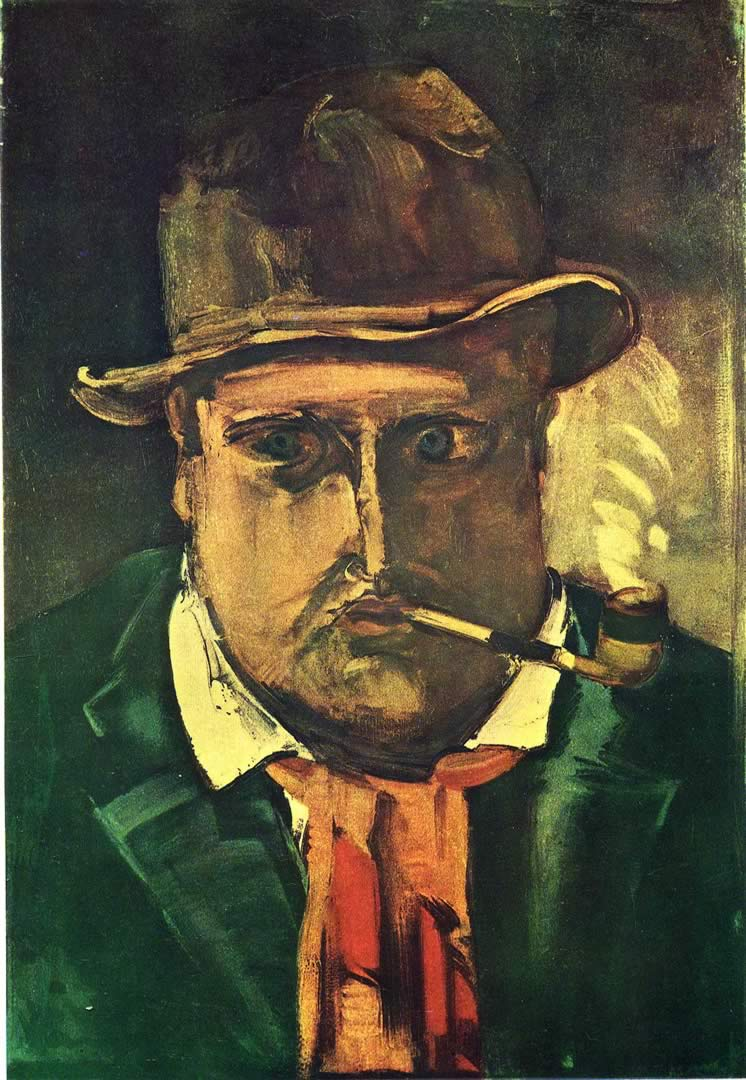What emotions do you think the artist wanted to convey through this painting? This expressionist painting likely aims to evoke feelings of solitude and introspection. The exaggerated features and dark colors may suggest deeper, perhaps somber, emotions, possibly reflecting the inner turmoil or contemplative state of the man depicted. 